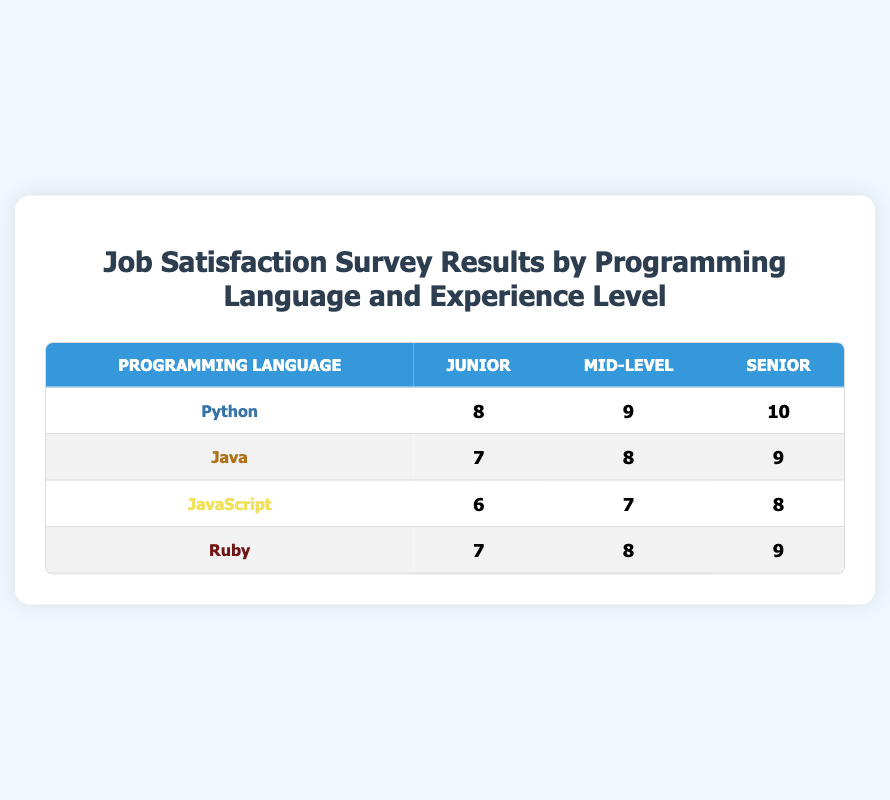What is the job satisfaction score for a Junior Python programmer? Looking at the row for Python under the Junior column, the job satisfaction score is given as 8
Answer: 8 Which programming language has the highest job satisfaction score for Senior developers? In the Senior column, the scores for Python, Java, JavaScript, and Ruby are 10, 9, 8, and 9 respectively. Python has the highest score of 10
Answer: Python What is the average job satisfaction score for Mid-Level developers across all programming languages? The scores for Mid-Level are 9 (Python), 8 (Java), 7 (JavaScript), and 8 (Ruby). The sum is 9 + 8 + 7 + 8 = 32, and there are 4 programming languages, so the average is 32 divided by 4, which is 8
Answer: 8 Do Junior JavaScript developers have a higher job satisfaction score than Junior Ruby developers? The Junior scores are 6 (JavaScript) and 7 (Ruby). Since 7 is greater than 6, the statement is true
Answer: Yes What is the total job satisfaction score for all levels of Java developers? The job satisfaction scores for Java developers across all levels are 7 (Junior), 8 (Mid-Level), and 9 (Senior). Adding these gives us 7 + 8 + 9 = 24
Answer: 24 Is it true that all programming languages have a job satisfaction score of at least 6 for Junior developers? The Junior scores are 8 (Python), 7 (Java), 6 (JavaScript), and 7 (Ruby). Since the lowest score is 6, which is not less than 6, the statement is true
Answer: Yes Which programming language has the lowest job satisfaction score for Mid-Level developers? In the Mid-Level column, the scores are 9 (Python), 8 (Java), 7 (JavaScript), and 8 (Ruby). JavaScript has the lowest score of 7
Answer: JavaScript What is the difference between the highest and lowest satisfaction scores in the table? The highest score is 10 (Python, Senior) and the lowest is 6 (JavaScript, Junior). The difference is 10 - 6 = 4
Answer: 4 